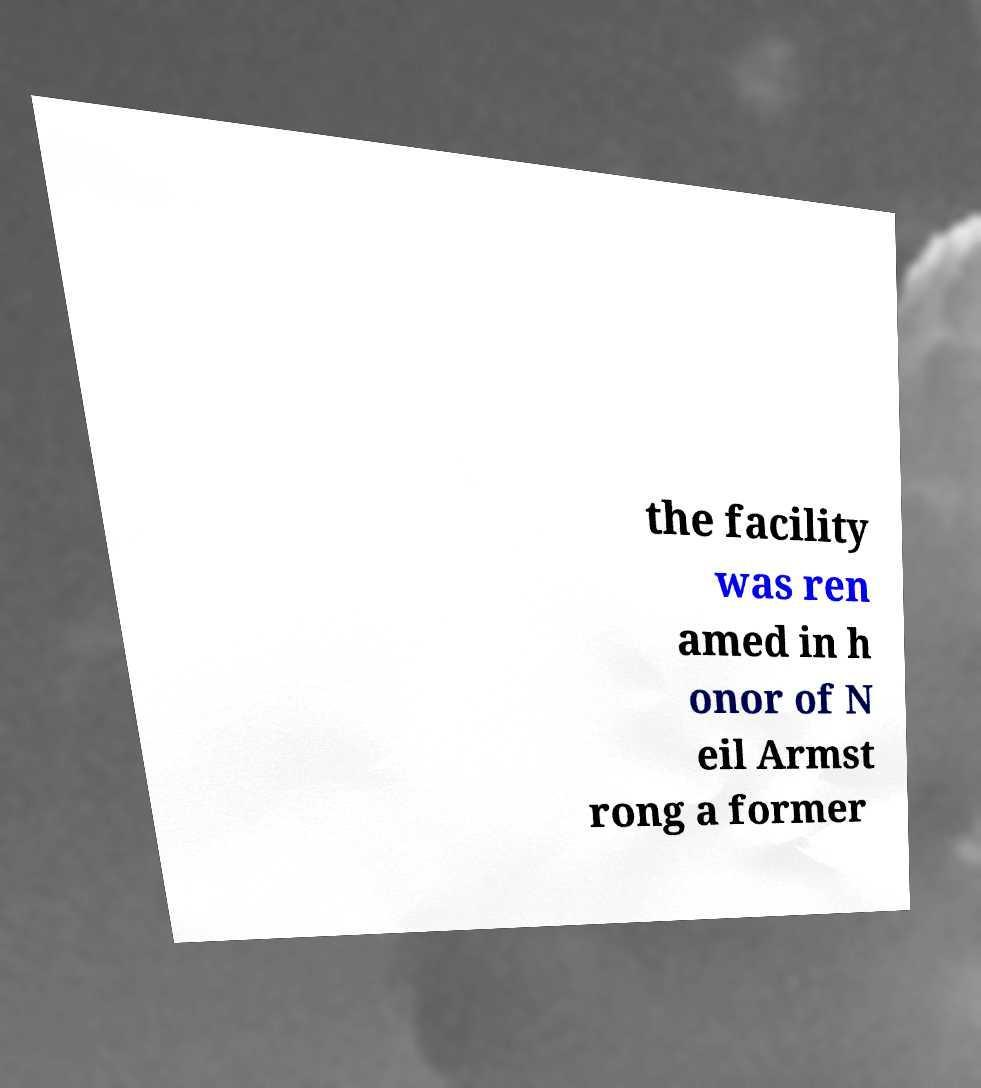There's text embedded in this image that I need extracted. Can you transcribe it verbatim? the facility was ren amed in h onor of N eil Armst rong a former 